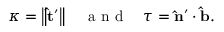Convert formula to latex. <formula><loc_0><loc_0><loc_500><loc_500>\begin{array} { r } { \kappa = \left \| \hat { t } ^ { \prime } \right \| \quad a n d \quad \tau = \hat { n } ^ { \prime } \cdot \hat { b } . } \end{array}</formula> 